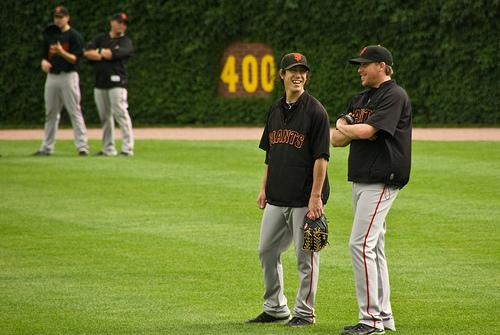Describe the setting where the baseball players are standing. The baseball players are standing on a green outfield grass field, with a brown warning track near a wall covered in green ivy. Mention the objective of the people depicted in the image. They are playing baseball and interacting with each other in the field. Give a brief summary about the objects and subjects in the image. The image features baseball players wearing black hats, grey pants, and holding a baseball glove. There's a yellow numbered sign, green outfield grass, and ivy growing on a wall. Count the number of players wearing grey pants in the image. There are at least four players wearing grey pants. Identify the color of the players' shoes. The players are wearing black shoes. What are the common colors of the hats worn by the players? The players are wearing black hats with orange logos. Is there any interaction happening between any two players? If yes, describe it. Yes, one player is smiling at another player in the image. What kind of glove is a player holding, and what are its colors? A player is holding a black and brown baseball glove. Identify any numbers present on the image. yellow number on wall Is the baseball glove pink and covered in glitter? There are mentions of black leather baseball gloves and a black and brown baseball glove, but no mention of a pink or glittery glove. Determine the emotion on the boy's face. smiling What kind of coat is a player wearing? black and orange jacket What does the warning track located near the wall look like? brown How would you characterize the vines covering the wall? leafy What does the man, who is wearing a black cap, have on his legs? grey pants Is one of the people in the scene female or male? State the gender and the object they are holding. Female holding a mitt What is happening on the outfield grass? the grass is growing Are the baseball players standing on a red field with white lines? No, it's not mentioned in the image. What would this caption be, should the style be focused on the appearance of a fence: "thestructure X:195 Y:23 W:30 H:30"? part of a fence Which of the following activities is being done in the image? Options: sitting, running, playing baseball playing baseball Two men are in close proximity, performing what activity? standing next to each other For the following choices, which color combination is associated with the baseball gloves? Options: black and white, black and brown, red and blue black and brown One of the baseball players is holding a glove, describe the glove. black and brown glove How would you describe the jerseys of the baseball players? part of a jersey What are the baseball players who have their arms folded wearing? black hats, black shirts, grey pants, and black shoes Which type of plants are growing on the wall? green ivy What is happening on the field in the image? four baseball players standing in field Describe the portion of the image that depicts an elbow. part of an elbow Is there a large scoreboard displaying the game's score in the background? While there is a sign with yellow numbers mentioned, there is no explicit mention of a scoreboard displaying the game's score. 